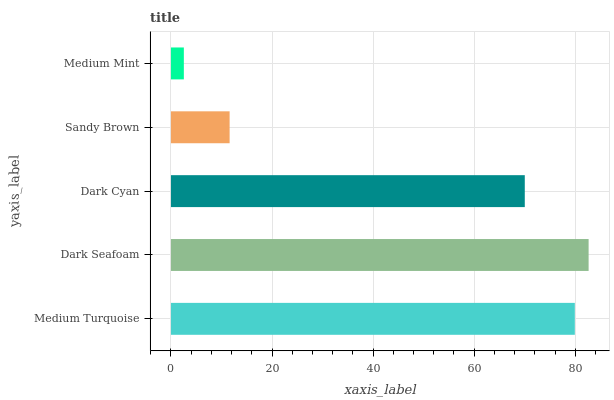Is Medium Mint the minimum?
Answer yes or no. Yes. Is Dark Seafoam the maximum?
Answer yes or no. Yes. Is Dark Cyan the minimum?
Answer yes or no. No. Is Dark Cyan the maximum?
Answer yes or no. No. Is Dark Seafoam greater than Dark Cyan?
Answer yes or no. Yes. Is Dark Cyan less than Dark Seafoam?
Answer yes or no. Yes. Is Dark Cyan greater than Dark Seafoam?
Answer yes or no. No. Is Dark Seafoam less than Dark Cyan?
Answer yes or no. No. Is Dark Cyan the high median?
Answer yes or no. Yes. Is Dark Cyan the low median?
Answer yes or no. Yes. Is Sandy Brown the high median?
Answer yes or no. No. Is Dark Seafoam the low median?
Answer yes or no. No. 